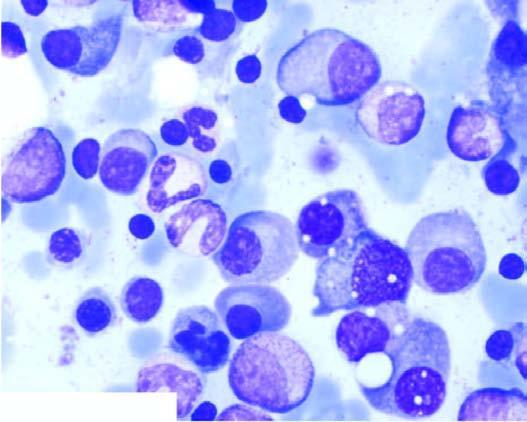what do bone marrow aspirate in myeloma show?
Answer the question using a single word or phrase. Numerous plasma cells 